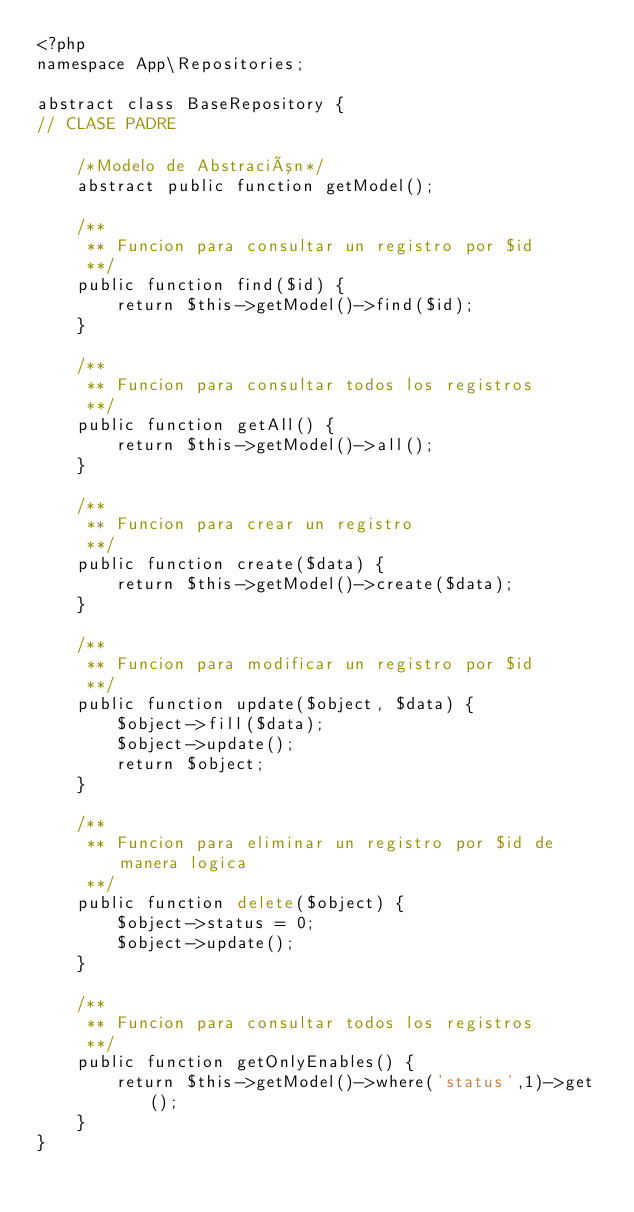<code> <loc_0><loc_0><loc_500><loc_500><_PHP_><?php
namespace App\Repositories;

abstract class BaseRepository {
// CLASE PADRE

    /*Modelo de Abstración*/
    abstract public function getModel();

    /**
     ** Funcion para consultar un registro por $id
     **/
    public function find($id) {
        return $this->getModel()->find($id);
    }

    /**
     ** Funcion para consultar todos los registros
     **/
    public function getAll() {
        return $this->getModel()->all();
    }

    /**
     ** Funcion para crear un registro
     **/
    public function create($data) {
        return $this->getModel()->create($data);
    }

    /**
     ** Funcion para modificar un registro por $id
     **/
    public function update($object, $data) {
        $object->fill($data);
        $object->update();
        return $object;
    }

    /**
     ** Funcion para eliminar un registro por $id de manera logica
     **/
    public function delete($object) {
        $object->status = 0;
        $object->update();
    }

    /**
     ** Funcion para consultar todos los registros
     **/
    public function getOnlyEnables() {
        return $this->getModel()->where('status',1)->get();
    }
}
</code> 